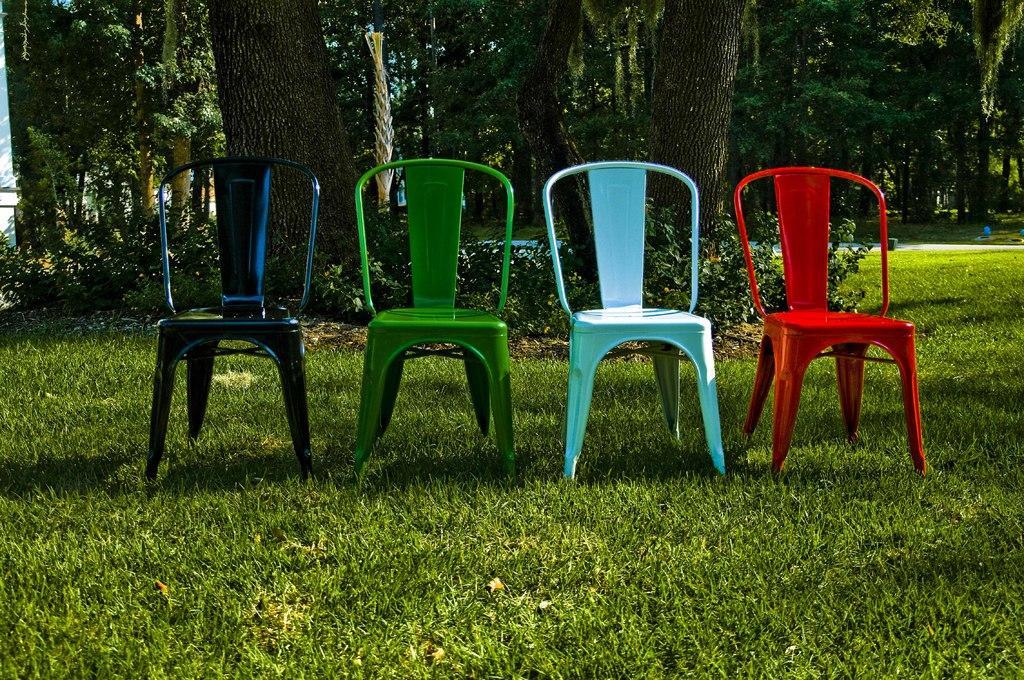Describe this image in one or two sentences. In this image I can see four chairs of different colors like red, sky blue, green and one is black color. I can see a ground full of grass. In the background I can see number of trees and a white wall. 